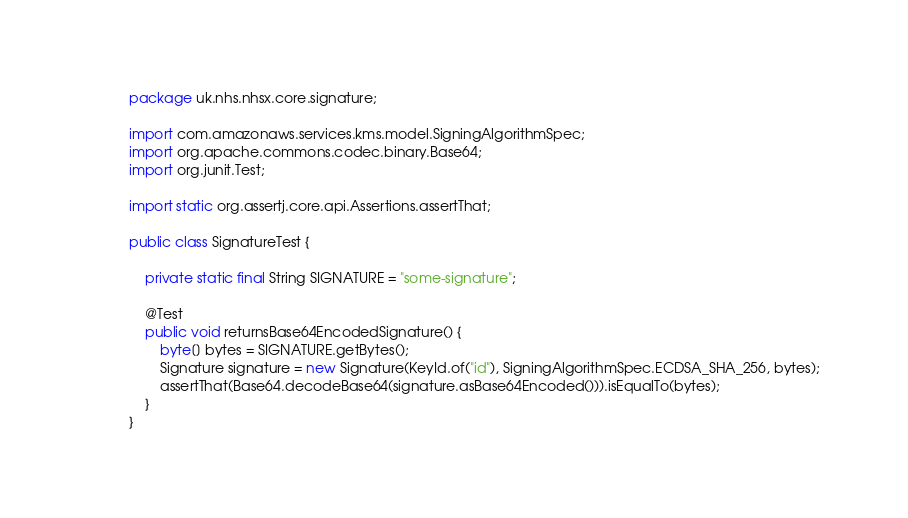Convert code to text. <code><loc_0><loc_0><loc_500><loc_500><_Java_>package uk.nhs.nhsx.core.signature;

import com.amazonaws.services.kms.model.SigningAlgorithmSpec;
import org.apache.commons.codec.binary.Base64;
import org.junit.Test;

import static org.assertj.core.api.Assertions.assertThat;

public class SignatureTest {

    private static final String SIGNATURE = "some-signature";

    @Test
    public void returnsBase64EncodedSignature() {
        byte[] bytes = SIGNATURE.getBytes();
        Signature signature = new Signature(KeyId.of("id"), SigningAlgorithmSpec.ECDSA_SHA_256, bytes);
        assertThat(Base64.decodeBase64(signature.asBase64Encoded())).isEqualTo(bytes);
    }
}</code> 